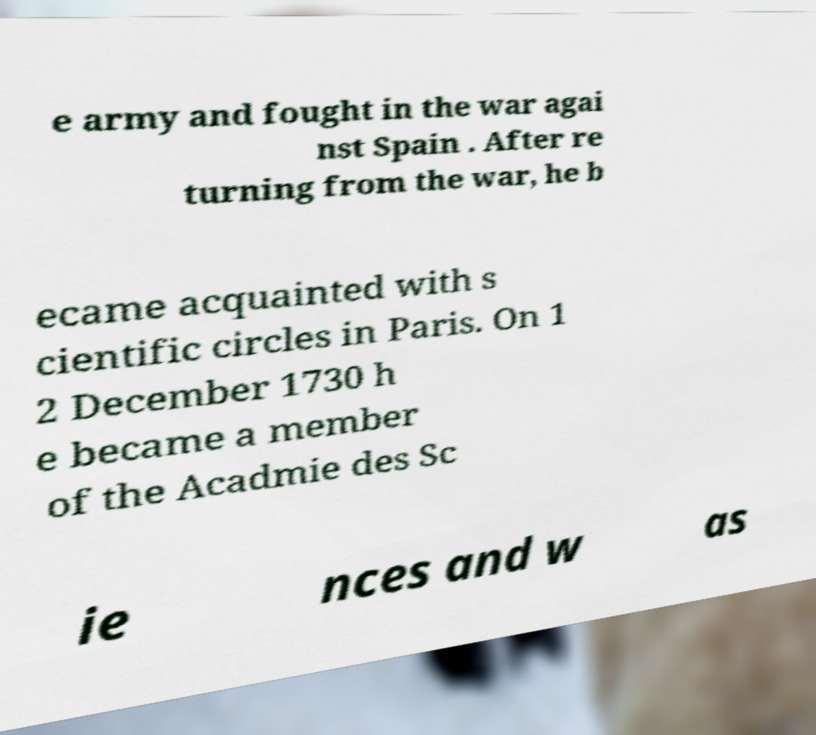Can you read and provide the text displayed in the image?This photo seems to have some interesting text. Can you extract and type it out for me? e army and fought in the war agai nst Spain . After re turning from the war, he b ecame acquainted with s cientific circles in Paris. On 1 2 December 1730 h e became a member of the Acadmie des Sc ie nces and w as 